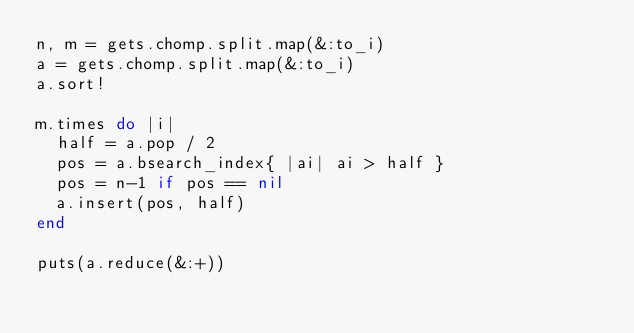Convert code to text. <code><loc_0><loc_0><loc_500><loc_500><_Ruby_>n, m = gets.chomp.split.map(&:to_i)
a = gets.chomp.split.map(&:to_i)
a.sort!

m.times do |i|
  half = a.pop / 2
  pos = a.bsearch_index{ |ai| ai > half }
  pos = n-1 if pos == nil
  a.insert(pos, half)
end

puts(a.reduce(&:+))</code> 